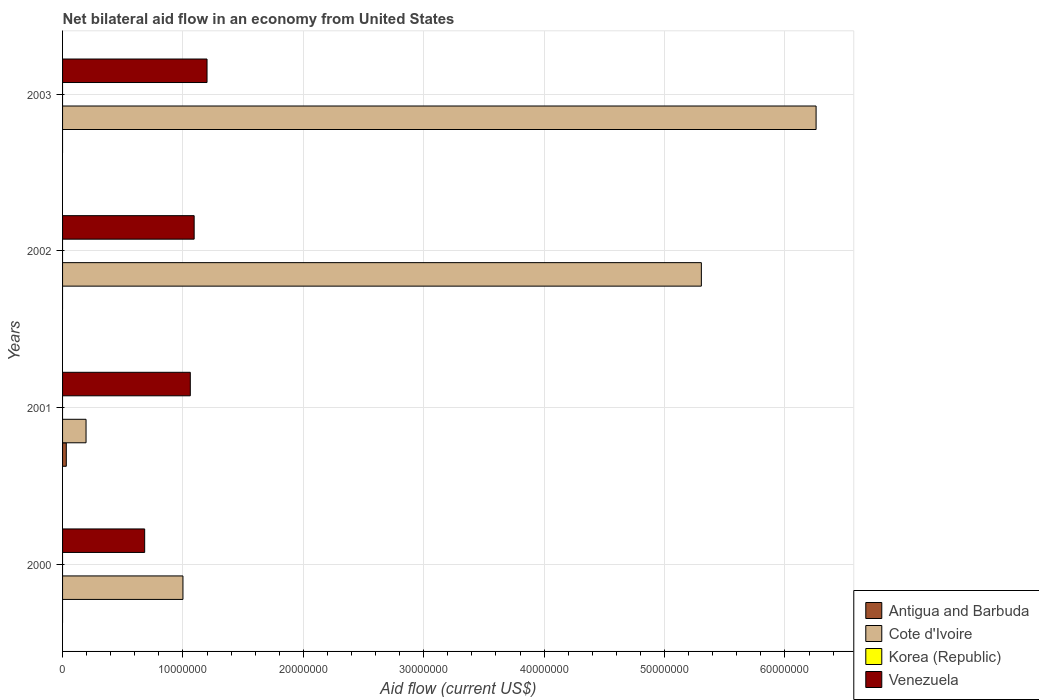How many groups of bars are there?
Provide a succinct answer. 4. Are the number of bars per tick equal to the number of legend labels?
Provide a short and direct response. No. How many bars are there on the 3rd tick from the bottom?
Your answer should be very brief. 2. Across all years, what is the maximum net bilateral aid flow in Cote d'Ivoire?
Provide a short and direct response. 6.26e+07. Across all years, what is the minimum net bilateral aid flow in Venezuela?
Ensure brevity in your answer.  6.82e+06. In which year was the net bilateral aid flow in Antigua and Barbuda maximum?
Provide a short and direct response. 2001. What is the difference between the net bilateral aid flow in Cote d'Ivoire in 2002 and that in 2003?
Ensure brevity in your answer.  -9.53e+06. What is the difference between the net bilateral aid flow in Cote d'Ivoire in 2001 and the net bilateral aid flow in Venezuela in 2003?
Offer a very short reply. -1.00e+07. What is the average net bilateral aid flow in Antigua and Barbuda per year?
Offer a terse response. 7.75e+04. In the year 2001, what is the difference between the net bilateral aid flow in Cote d'Ivoire and net bilateral aid flow in Antigua and Barbuda?
Provide a succinct answer. 1.64e+06. What is the ratio of the net bilateral aid flow in Venezuela in 2001 to that in 2002?
Give a very brief answer. 0.97. Is the sum of the net bilateral aid flow in Cote d'Ivoire in 2001 and 2002 greater than the maximum net bilateral aid flow in Korea (Republic) across all years?
Provide a short and direct response. Yes. Is it the case that in every year, the sum of the net bilateral aid flow in Korea (Republic) and net bilateral aid flow in Cote d'Ivoire is greater than the sum of net bilateral aid flow in Venezuela and net bilateral aid flow in Antigua and Barbuda?
Provide a short and direct response. Yes. How many bars are there?
Make the answer very short. 9. How many years are there in the graph?
Make the answer very short. 4. Are the values on the major ticks of X-axis written in scientific E-notation?
Your answer should be compact. No. Does the graph contain any zero values?
Ensure brevity in your answer.  Yes. Does the graph contain grids?
Keep it short and to the point. Yes. What is the title of the graph?
Make the answer very short. Net bilateral aid flow in an economy from United States. Does "Latin America(developing only)" appear as one of the legend labels in the graph?
Provide a short and direct response. No. What is the label or title of the Y-axis?
Your response must be concise. Years. What is the Aid flow (current US$) of Cote d'Ivoire in 2000?
Keep it short and to the point. 1.00e+07. What is the Aid flow (current US$) of Korea (Republic) in 2000?
Keep it short and to the point. 0. What is the Aid flow (current US$) of Venezuela in 2000?
Keep it short and to the point. 6.82e+06. What is the Aid flow (current US$) in Antigua and Barbuda in 2001?
Ensure brevity in your answer.  3.10e+05. What is the Aid flow (current US$) of Cote d'Ivoire in 2001?
Your response must be concise. 1.95e+06. What is the Aid flow (current US$) in Korea (Republic) in 2001?
Give a very brief answer. 0. What is the Aid flow (current US$) of Venezuela in 2001?
Provide a short and direct response. 1.06e+07. What is the Aid flow (current US$) in Cote d'Ivoire in 2002?
Provide a short and direct response. 5.31e+07. What is the Aid flow (current US$) in Venezuela in 2002?
Provide a succinct answer. 1.09e+07. What is the Aid flow (current US$) of Cote d'Ivoire in 2003?
Your answer should be compact. 6.26e+07. What is the Aid flow (current US$) of Venezuela in 2003?
Your answer should be very brief. 1.20e+07. Across all years, what is the maximum Aid flow (current US$) in Cote d'Ivoire?
Ensure brevity in your answer.  6.26e+07. Across all years, what is the minimum Aid flow (current US$) of Antigua and Barbuda?
Offer a terse response. 0. Across all years, what is the minimum Aid flow (current US$) of Cote d'Ivoire?
Provide a succinct answer. 1.95e+06. Across all years, what is the minimum Aid flow (current US$) of Venezuela?
Provide a succinct answer. 6.82e+06. What is the total Aid flow (current US$) of Antigua and Barbuda in the graph?
Offer a terse response. 3.10e+05. What is the total Aid flow (current US$) in Cote d'Ivoire in the graph?
Your answer should be very brief. 1.28e+08. What is the total Aid flow (current US$) of Korea (Republic) in the graph?
Provide a short and direct response. 0. What is the total Aid flow (current US$) of Venezuela in the graph?
Provide a succinct answer. 4.04e+07. What is the difference between the Aid flow (current US$) in Cote d'Ivoire in 2000 and that in 2001?
Your answer should be compact. 8.05e+06. What is the difference between the Aid flow (current US$) in Venezuela in 2000 and that in 2001?
Offer a very short reply. -3.79e+06. What is the difference between the Aid flow (current US$) of Cote d'Ivoire in 2000 and that in 2002?
Keep it short and to the point. -4.31e+07. What is the difference between the Aid flow (current US$) of Venezuela in 2000 and that in 2002?
Your answer should be compact. -4.11e+06. What is the difference between the Aid flow (current US$) of Cote d'Ivoire in 2000 and that in 2003?
Offer a terse response. -5.26e+07. What is the difference between the Aid flow (current US$) of Venezuela in 2000 and that in 2003?
Provide a short and direct response. -5.18e+06. What is the difference between the Aid flow (current US$) of Cote d'Ivoire in 2001 and that in 2002?
Provide a short and direct response. -5.11e+07. What is the difference between the Aid flow (current US$) in Venezuela in 2001 and that in 2002?
Your answer should be very brief. -3.20e+05. What is the difference between the Aid flow (current US$) of Cote d'Ivoire in 2001 and that in 2003?
Offer a terse response. -6.06e+07. What is the difference between the Aid flow (current US$) in Venezuela in 2001 and that in 2003?
Provide a short and direct response. -1.39e+06. What is the difference between the Aid flow (current US$) of Cote d'Ivoire in 2002 and that in 2003?
Offer a very short reply. -9.53e+06. What is the difference between the Aid flow (current US$) of Venezuela in 2002 and that in 2003?
Give a very brief answer. -1.07e+06. What is the difference between the Aid flow (current US$) in Cote d'Ivoire in 2000 and the Aid flow (current US$) in Venezuela in 2001?
Your answer should be very brief. -6.10e+05. What is the difference between the Aid flow (current US$) in Cote d'Ivoire in 2000 and the Aid flow (current US$) in Venezuela in 2002?
Keep it short and to the point. -9.30e+05. What is the difference between the Aid flow (current US$) in Antigua and Barbuda in 2001 and the Aid flow (current US$) in Cote d'Ivoire in 2002?
Provide a succinct answer. -5.28e+07. What is the difference between the Aid flow (current US$) in Antigua and Barbuda in 2001 and the Aid flow (current US$) in Venezuela in 2002?
Ensure brevity in your answer.  -1.06e+07. What is the difference between the Aid flow (current US$) in Cote d'Ivoire in 2001 and the Aid flow (current US$) in Venezuela in 2002?
Your answer should be very brief. -8.98e+06. What is the difference between the Aid flow (current US$) of Antigua and Barbuda in 2001 and the Aid flow (current US$) of Cote d'Ivoire in 2003?
Keep it short and to the point. -6.23e+07. What is the difference between the Aid flow (current US$) of Antigua and Barbuda in 2001 and the Aid flow (current US$) of Venezuela in 2003?
Keep it short and to the point. -1.17e+07. What is the difference between the Aid flow (current US$) in Cote d'Ivoire in 2001 and the Aid flow (current US$) in Venezuela in 2003?
Keep it short and to the point. -1.00e+07. What is the difference between the Aid flow (current US$) of Cote d'Ivoire in 2002 and the Aid flow (current US$) of Venezuela in 2003?
Make the answer very short. 4.11e+07. What is the average Aid flow (current US$) in Antigua and Barbuda per year?
Your response must be concise. 7.75e+04. What is the average Aid flow (current US$) of Cote d'Ivoire per year?
Provide a succinct answer. 3.19e+07. What is the average Aid flow (current US$) in Korea (Republic) per year?
Keep it short and to the point. 0. What is the average Aid flow (current US$) in Venezuela per year?
Provide a succinct answer. 1.01e+07. In the year 2000, what is the difference between the Aid flow (current US$) of Cote d'Ivoire and Aid flow (current US$) of Venezuela?
Provide a short and direct response. 3.18e+06. In the year 2001, what is the difference between the Aid flow (current US$) of Antigua and Barbuda and Aid flow (current US$) of Cote d'Ivoire?
Your answer should be very brief. -1.64e+06. In the year 2001, what is the difference between the Aid flow (current US$) of Antigua and Barbuda and Aid flow (current US$) of Venezuela?
Provide a short and direct response. -1.03e+07. In the year 2001, what is the difference between the Aid flow (current US$) in Cote d'Ivoire and Aid flow (current US$) in Venezuela?
Keep it short and to the point. -8.66e+06. In the year 2002, what is the difference between the Aid flow (current US$) of Cote d'Ivoire and Aid flow (current US$) of Venezuela?
Your response must be concise. 4.21e+07. In the year 2003, what is the difference between the Aid flow (current US$) in Cote d'Ivoire and Aid flow (current US$) in Venezuela?
Keep it short and to the point. 5.06e+07. What is the ratio of the Aid flow (current US$) in Cote d'Ivoire in 2000 to that in 2001?
Offer a terse response. 5.13. What is the ratio of the Aid flow (current US$) in Venezuela in 2000 to that in 2001?
Your answer should be compact. 0.64. What is the ratio of the Aid flow (current US$) of Cote d'Ivoire in 2000 to that in 2002?
Offer a terse response. 0.19. What is the ratio of the Aid flow (current US$) in Venezuela in 2000 to that in 2002?
Your answer should be very brief. 0.62. What is the ratio of the Aid flow (current US$) of Cote d'Ivoire in 2000 to that in 2003?
Ensure brevity in your answer.  0.16. What is the ratio of the Aid flow (current US$) in Venezuela in 2000 to that in 2003?
Ensure brevity in your answer.  0.57. What is the ratio of the Aid flow (current US$) of Cote d'Ivoire in 2001 to that in 2002?
Provide a succinct answer. 0.04. What is the ratio of the Aid flow (current US$) in Venezuela in 2001 to that in 2002?
Keep it short and to the point. 0.97. What is the ratio of the Aid flow (current US$) in Cote d'Ivoire in 2001 to that in 2003?
Your response must be concise. 0.03. What is the ratio of the Aid flow (current US$) of Venezuela in 2001 to that in 2003?
Ensure brevity in your answer.  0.88. What is the ratio of the Aid flow (current US$) of Cote d'Ivoire in 2002 to that in 2003?
Offer a very short reply. 0.85. What is the ratio of the Aid flow (current US$) in Venezuela in 2002 to that in 2003?
Your response must be concise. 0.91. What is the difference between the highest and the second highest Aid flow (current US$) of Cote d'Ivoire?
Provide a short and direct response. 9.53e+06. What is the difference between the highest and the second highest Aid flow (current US$) of Venezuela?
Your answer should be compact. 1.07e+06. What is the difference between the highest and the lowest Aid flow (current US$) in Cote d'Ivoire?
Your answer should be very brief. 6.06e+07. What is the difference between the highest and the lowest Aid flow (current US$) in Venezuela?
Provide a succinct answer. 5.18e+06. 